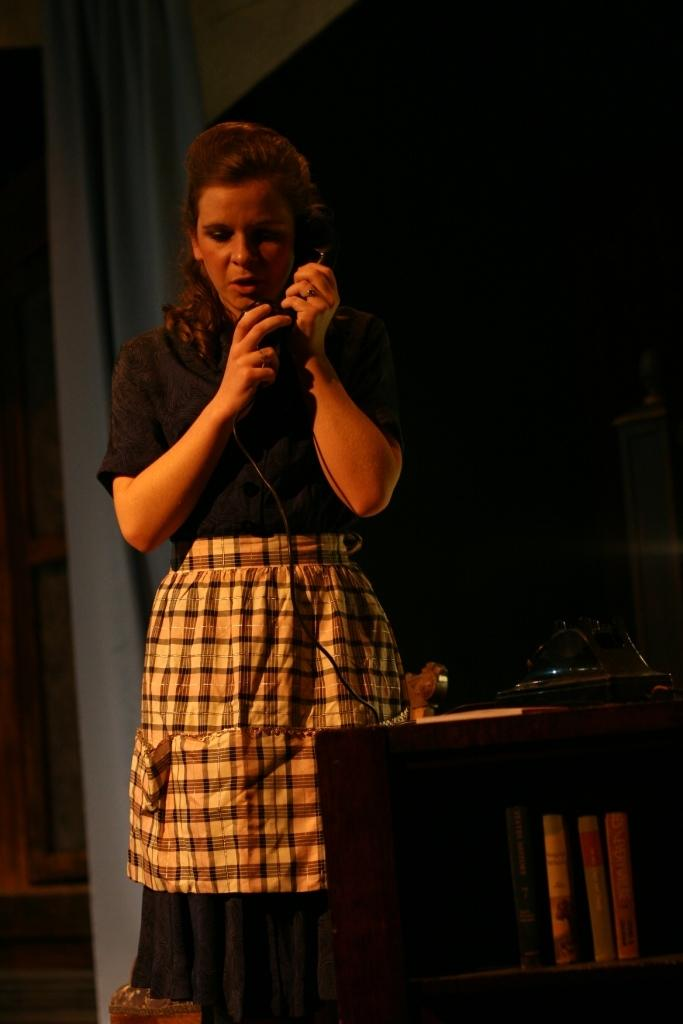Who is the main subject in the image? There is a woman in the image. What is the woman doing in the image? The woman is standing in the image. What object is the woman holding? The woman is holding a telephone. What can be seen on the right side of the image? There is a table on the right side of the image. What items are on the table? There are books on the table. What is visible in the background of the image? There is a curtain in the background of the image. What route does the woman take to travel back in time in the image? There is no indication in the image that the woman is traveling back in time or using any route for such a purpose. 